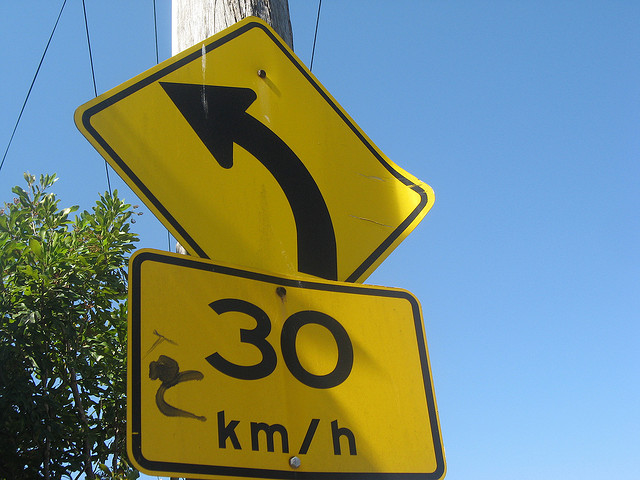Identify the text contained in this image. Km / h 30 